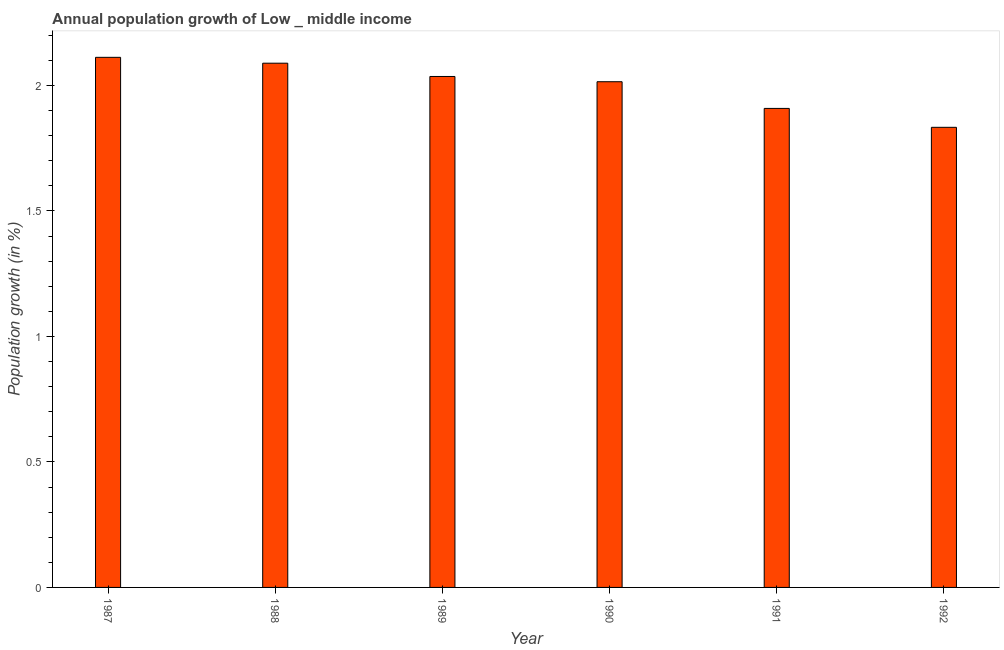Does the graph contain grids?
Offer a terse response. No. What is the title of the graph?
Provide a succinct answer. Annual population growth of Low _ middle income. What is the label or title of the X-axis?
Your response must be concise. Year. What is the label or title of the Y-axis?
Offer a terse response. Population growth (in %). What is the population growth in 1990?
Your answer should be compact. 2.01. Across all years, what is the maximum population growth?
Provide a succinct answer. 2.11. Across all years, what is the minimum population growth?
Provide a short and direct response. 1.83. What is the sum of the population growth?
Keep it short and to the point. 11.99. What is the difference between the population growth in 1987 and 1990?
Give a very brief answer. 0.1. What is the average population growth per year?
Give a very brief answer. 2. What is the median population growth?
Your response must be concise. 2.03. In how many years, is the population growth greater than 1.4 %?
Keep it short and to the point. 6. Do a majority of the years between 1990 and 1989 (inclusive) have population growth greater than 1.3 %?
Offer a terse response. No. What is the ratio of the population growth in 1989 to that in 1991?
Offer a terse response. 1.07. What is the difference between the highest and the second highest population growth?
Your response must be concise. 0.02. Is the sum of the population growth in 1988 and 1990 greater than the maximum population growth across all years?
Offer a terse response. Yes. What is the difference between the highest and the lowest population growth?
Offer a terse response. 0.28. In how many years, is the population growth greater than the average population growth taken over all years?
Your answer should be compact. 4. What is the Population growth (in %) in 1987?
Provide a succinct answer. 2.11. What is the Population growth (in %) of 1988?
Your response must be concise. 2.09. What is the Population growth (in %) in 1989?
Ensure brevity in your answer.  2.04. What is the Population growth (in %) of 1990?
Give a very brief answer. 2.01. What is the Population growth (in %) in 1991?
Keep it short and to the point. 1.91. What is the Population growth (in %) in 1992?
Provide a short and direct response. 1.83. What is the difference between the Population growth (in %) in 1987 and 1988?
Keep it short and to the point. 0.02. What is the difference between the Population growth (in %) in 1987 and 1989?
Your answer should be compact. 0.08. What is the difference between the Population growth (in %) in 1987 and 1990?
Give a very brief answer. 0.1. What is the difference between the Population growth (in %) in 1987 and 1991?
Make the answer very short. 0.2. What is the difference between the Population growth (in %) in 1987 and 1992?
Keep it short and to the point. 0.28. What is the difference between the Population growth (in %) in 1988 and 1989?
Give a very brief answer. 0.05. What is the difference between the Population growth (in %) in 1988 and 1990?
Make the answer very short. 0.07. What is the difference between the Population growth (in %) in 1988 and 1991?
Your answer should be very brief. 0.18. What is the difference between the Population growth (in %) in 1988 and 1992?
Offer a terse response. 0.26. What is the difference between the Population growth (in %) in 1989 and 1990?
Ensure brevity in your answer.  0.02. What is the difference between the Population growth (in %) in 1989 and 1991?
Give a very brief answer. 0.13. What is the difference between the Population growth (in %) in 1989 and 1992?
Your response must be concise. 0.2. What is the difference between the Population growth (in %) in 1990 and 1991?
Offer a terse response. 0.11. What is the difference between the Population growth (in %) in 1990 and 1992?
Ensure brevity in your answer.  0.18. What is the difference between the Population growth (in %) in 1991 and 1992?
Provide a short and direct response. 0.08. What is the ratio of the Population growth (in %) in 1987 to that in 1988?
Provide a short and direct response. 1.01. What is the ratio of the Population growth (in %) in 1987 to that in 1989?
Your answer should be compact. 1.04. What is the ratio of the Population growth (in %) in 1987 to that in 1990?
Make the answer very short. 1.05. What is the ratio of the Population growth (in %) in 1987 to that in 1991?
Keep it short and to the point. 1.11. What is the ratio of the Population growth (in %) in 1987 to that in 1992?
Your answer should be very brief. 1.15. What is the ratio of the Population growth (in %) in 1988 to that in 1989?
Make the answer very short. 1.03. What is the ratio of the Population growth (in %) in 1988 to that in 1991?
Ensure brevity in your answer.  1.09. What is the ratio of the Population growth (in %) in 1988 to that in 1992?
Your answer should be compact. 1.14. What is the ratio of the Population growth (in %) in 1989 to that in 1991?
Offer a terse response. 1.07. What is the ratio of the Population growth (in %) in 1989 to that in 1992?
Give a very brief answer. 1.11. What is the ratio of the Population growth (in %) in 1990 to that in 1991?
Offer a very short reply. 1.06. What is the ratio of the Population growth (in %) in 1990 to that in 1992?
Your answer should be compact. 1.1. What is the ratio of the Population growth (in %) in 1991 to that in 1992?
Offer a terse response. 1.04. 